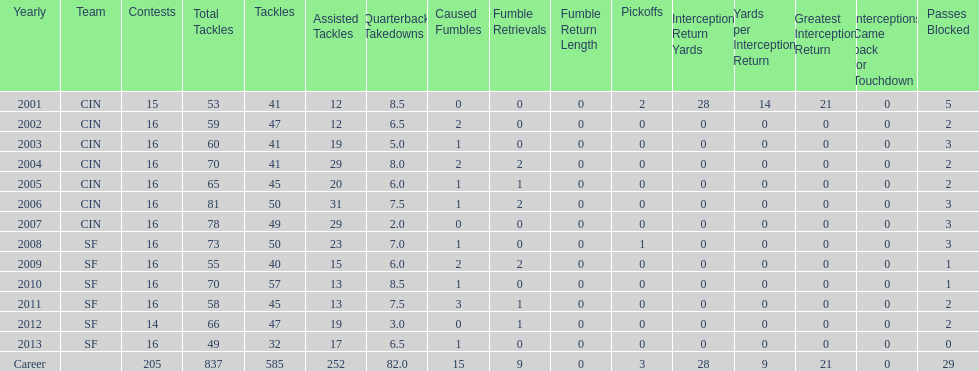What was the number of combined tackles in 2010? 70. 